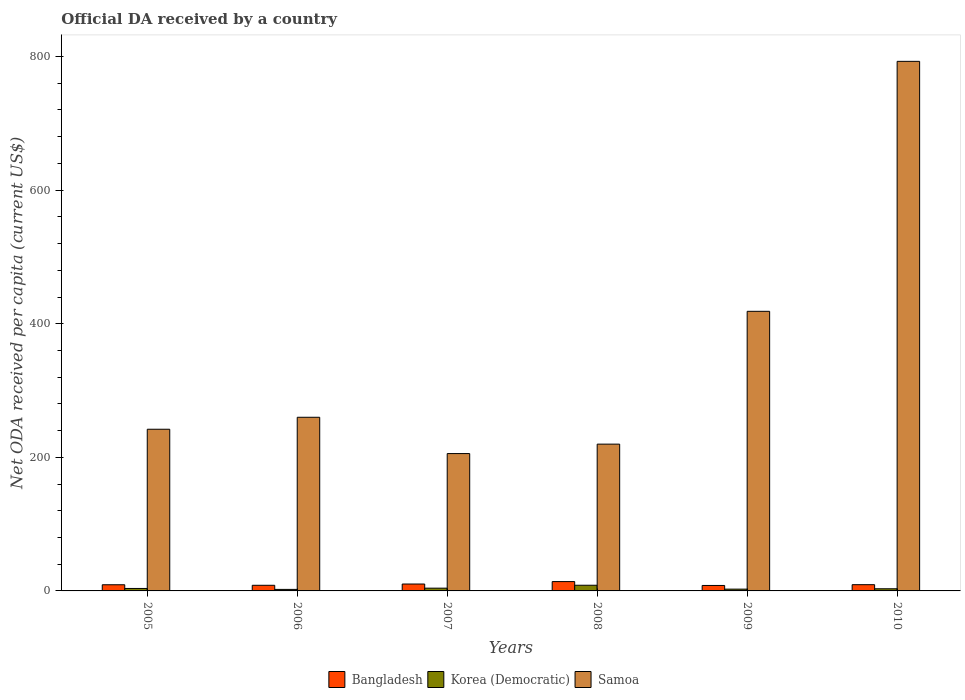How many different coloured bars are there?
Offer a terse response. 3. How many groups of bars are there?
Ensure brevity in your answer.  6. What is the ODA received in in Korea (Democratic) in 2009?
Offer a terse response. 2.68. Across all years, what is the maximum ODA received in in Korea (Democratic)?
Your response must be concise. 8.5. Across all years, what is the minimum ODA received in in Samoa?
Your answer should be compact. 205.61. What is the total ODA received in in Bangladesh in the graph?
Provide a short and direct response. 59.47. What is the difference between the ODA received in in Korea (Democratic) in 2006 and that in 2007?
Your answer should be very brief. -1.84. What is the difference between the ODA received in in Samoa in 2010 and the ODA received in in Bangladesh in 2009?
Your response must be concise. 784.6. What is the average ODA received in in Korea (Democratic) per year?
Keep it short and to the point. 4.08. In the year 2007, what is the difference between the ODA received in in Bangladesh and ODA received in in Korea (Democratic)?
Your response must be concise. 6.22. What is the ratio of the ODA received in in Samoa in 2009 to that in 2010?
Offer a terse response. 0.53. Is the ODA received in in Korea (Democratic) in 2005 less than that in 2010?
Make the answer very short. No. Is the difference between the ODA received in in Bangladesh in 2005 and 2006 greater than the difference between the ODA received in in Korea (Democratic) in 2005 and 2006?
Your response must be concise. No. What is the difference between the highest and the second highest ODA received in in Bangladesh?
Give a very brief answer. 3.63. What is the difference between the highest and the lowest ODA received in in Samoa?
Your answer should be compact. 587.17. Is the sum of the ODA received in in Samoa in 2005 and 2007 greater than the maximum ODA received in in Korea (Democratic) across all years?
Ensure brevity in your answer.  Yes. What does the 3rd bar from the left in 2006 represents?
Your answer should be compact. Samoa. What does the 1st bar from the right in 2008 represents?
Make the answer very short. Samoa. Is it the case that in every year, the sum of the ODA received in in Samoa and ODA received in in Bangladesh is greater than the ODA received in in Korea (Democratic)?
Give a very brief answer. Yes. What is the difference between two consecutive major ticks on the Y-axis?
Provide a short and direct response. 200. Are the values on the major ticks of Y-axis written in scientific E-notation?
Your answer should be very brief. No. Does the graph contain any zero values?
Ensure brevity in your answer.  No. Does the graph contain grids?
Offer a terse response. No. Where does the legend appear in the graph?
Provide a succinct answer. Bottom center. How are the legend labels stacked?
Make the answer very short. Horizontal. What is the title of the graph?
Give a very brief answer. Official DA received by a country. What is the label or title of the Y-axis?
Your answer should be compact. Net ODA received per capita (current US$). What is the Net ODA received per capita (current US$) in Bangladesh in 2005?
Ensure brevity in your answer.  9.23. What is the Net ODA received per capita (current US$) in Korea (Democratic) in 2005?
Your answer should be very brief. 3.68. What is the Net ODA received per capita (current US$) of Samoa in 2005?
Keep it short and to the point. 242.04. What is the Net ODA received per capita (current US$) of Bangladesh in 2006?
Ensure brevity in your answer.  8.43. What is the Net ODA received per capita (current US$) of Korea (Democratic) in 2006?
Make the answer very short. 2.28. What is the Net ODA received per capita (current US$) of Samoa in 2006?
Keep it short and to the point. 259.95. What is the Net ODA received per capita (current US$) of Bangladesh in 2007?
Make the answer very short. 10.34. What is the Net ODA received per capita (current US$) in Korea (Democratic) in 2007?
Offer a very short reply. 4.12. What is the Net ODA received per capita (current US$) in Samoa in 2007?
Give a very brief answer. 205.61. What is the Net ODA received per capita (current US$) of Bangladesh in 2008?
Your answer should be very brief. 13.97. What is the Net ODA received per capita (current US$) in Korea (Democratic) in 2008?
Provide a succinct answer. 8.5. What is the Net ODA received per capita (current US$) in Samoa in 2008?
Your answer should be very brief. 219.74. What is the Net ODA received per capita (current US$) in Bangladesh in 2009?
Make the answer very short. 8.18. What is the Net ODA received per capita (current US$) in Korea (Democratic) in 2009?
Provide a short and direct response. 2.68. What is the Net ODA received per capita (current US$) in Samoa in 2009?
Keep it short and to the point. 418.57. What is the Net ODA received per capita (current US$) in Bangladesh in 2010?
Provide a short and direct response. 9.33. What is the Net ODA received per capita (current US$) in Korea (Democratic) in 2010?
Keep it short and to the point. 3.22. What is the Net ODA received per capita (current US$) of Samoa in 2010?
Your answer should be very brief. 792.78. Across all years, what is the maximum Net ODA received per capita (current US$) in Bangladesh?
Your answer should be very brief. 13.97. Across all years, what is the maximum Net ODA received per capita (current US$) of Korea (Democratic)?
Provide a succinct answer. 8.5. Across all years, what is the maximum Net ODA received per capita (current US$) in Samoa?
Offer a terse response. 792.78. Across all years, what is the minimum Net ODA received per capita (current US$) of Bangladesh?
Offer a terse response. 8.18. Across all years, what is the minimum Net ODA received per capita (current US$) in Korea (Democratic)?
Offer a very short reply. 2.28. Across all years, what is the minimum Net ODA received per capita (current US$) of Samoa?
Provide a short and direct response. 205.61. What is the total Net ODA received per capita (current US$) of Bangladesh in the graph?
Keep it short and to the point. 59.47. What is the total Net ODA received per capita (current US$) in Korea (Democratic) in the graph?
Offer a very short reply. 24.47. What is the total Net ODA received per capita (current US$) of Samoa in the graph?
Your response must be concise. 2138.7. What is the difference between the Net ODA received per capita (current US$) of Bangladesh in 2005 and that in 2006?
Your response must be concise. 0.8. What is the difference between the Net ODA received per capita (current US$) of Korea (Democratic) in 2005 and that in 2006?
Your answer should be compact. 1.4. What is the difference between the Net ODA received per capita (current US$) of Samoa in 2005 and that in 2006?
Keep it short and to the point. -17.91. What is the difference between the Net ODA received per capita (current US$) of Bangladesh in 2005 and that in 2007?
Your answer should be very brief. -1.11. What is the difference between the Net ODA received per capita (current US$) in Korea (Democratic) in 2005 and that in 2007?
Keep it short and to the point. -0.44. What is the difference between the Net ODA received per capita (current US$) of Samoa in 2005 and that in 2007?
Keep it short and to the point. 36.43. What is the difference between the Net ODA received per capita (current US$) in Bangladesh in 2005 and that in 2008?
Your response must be concise. -4.74. What is the difference between the Net ODA received per capita (current US$) in Korea (Democratic) in 2005 and that in 2008?
Give a very brief answer. -4.83. What is the difference between the Net ODA received per capita (current US$) in Samoa in 2005 and that in 2008?
Provide a succinct answer. 22.3. What is the difference between the Net ODA received per capita (current US$) in Samoa in 2005 and that in 2009?
Provide a short and direct response. -176.53. What is the difference between the Net ODA received per capita (current US$) of Bangladesh in 2005 and that in 2010?
Offer a very short reply. -0.11. What is the difference between the Net ODA received per capita (current US$) of Korea (Democratic) in 2005 and that in 2010?
Your answer should be very brief. 0.46. What is the difference between the Net ODA received per capita (current US$) of Samoa in 2005 and that in 2010?
Ensure brevity in your answer.  -550.74. What is the difference between the Net ODA received per capita (current US$) in Bangladesh in 2006 and that in 2007?
Offer a terse response. -1.91. What is the difference between the Net ODA received per capita (current US$) in Korea (Democratic) in 2006 and that in 2007?
Your answer should be very brief. -1.84. What is the difference between the Net ODA received per capita (current US$) of Samoa in 2006 and that in 2007?
Offer a terse response. 54.34. What is the difference between the Net ODA received per capita (current US$) of Bangladesh in 2006 and that in 2008?
Ensure brevity in your answer.  -5.54. What is the difference between the Net ODA received per capita (current US$) of Korea (Democratic) in 2006 and that in 2008?
Provide a short and direct response. -6.22. What is the difference between the Net ODA received per capita (current US$) of Samoa in 2006 and that in 2008?
Your answer should be compact. 40.21. What is the difference between the Net ODA received per capita (current US$) in Bangladesh in 2006 and that in 2009?
Provide a succinct answer. 0.25. What is the difference between the Net ODA received per capita (current US$) of Korea (Democratic) in 2006 and that in 2009?
Make the answer very short. -0.4. What is the difference between the Net ODA received per capita (current US$) of Samoa in 2006 and that in 2009?
Make the answer very short. -158.62. What is the difference between the Net ODA received per capita (current US$) in Bangladesh in 2006 and that in 2010?
Offer a very short reply. -0.9. What is the difference between the Net ODA received per capita (current US$) in Korea (Democratic) in 2006 and that in 2010?
Make the answer very short. -0.94. What is the difference between the Net ODA received per capita (current US$) of Samoa in 2006 and that in 2010?
Give a very brief answer. -532.83. What is the difference between the Net ODA received per capita (current US$) of Bangladesh in 2007 and that in 2008?
Your response must be concise. -3.63. What is the difference between the Net ODA received per capita (current US$) of Korea (Democratic) in 2007 and that in 2008?
Make the answer very short. -4.39. What is the difference between the Net ODA received per capita (current US$) in Samoa in 2007 and that in 2008?
Your answer should be very brief. -14.13. What is the difference between the Net ODA received per capita (current US$) in Bangladesh in 2007 and that in 2009?
Provide a succinct answer. 2.16. What is the difference between the Net ODA received per capita (current US$) in Korea (Democratic) in 2007 and that in 2009?
Provide a succinct answer. 1.44. What is the difference between the Net ODA received per capita (current US$) of Samoa in 2007 and that in 2009?
Provide a short and direct response. -212.96. What is the difference between the Net ODA received per capita (current US$) in Bangladesh in 2007 and that in 2010?
Ensure brevity in your answer.  1. What is the difference between the Net ODA received per capita (current US$) in Samoa in 2007 and that in 2010?
Ensure brevity in your answer.  -587.17. What is the difference between the Net ODA received per capita (current US$) in Bangladesh in 2008 and that in 2009?
Your answer should be compact. 5.79. What is the difference between the Net ODA received per capita (current US$) in Korea (Democratic) in 2008 and that in 2009?
Provide a short and direct response. 5.83. What is the difference between the Net ODA received per capita (current US$) in Samoa in 2008 and that in 2009?
Keep it short and to the point. -198.83. What is the difference between the Net ODA received per capita (current US$) of Bangladesh in 2008 and that in 2010?
Give a very brief answer. 4.63. What is the difference between the Net ODA received per capita (current US$) of Korea (Democratic) in 2008 and that in 2010?
Your answer should be very brief. 5.29. What is the difference between the Net ODA received per capita (current US$) in Samoa in 2008 and that in 2010?
Make the answer very short. -573.03. What is the difference between the Net ODA received per capita (current US$) in Bangladesh in 2009 and that in 2010?
Provide a succinct answer. -1.16. What is the difference between the Net ODA received per capita (current US$) of Korea (Democratic) in 2009 and that in 2010?
Ensure brevity in your answer.  -0.54. What is the difference between the Net ODA received per capita (current US$) of Samoa in 2009 and that in 2010?
Make the answer very short. -374.21. What is the difference between the Net ODA received per capita (current US$) in Bangladesh in 2005 and the Net ODA received per capita (current US$) in Korea (Democratic) in 2006?
Provide a short and direct response. 6.95. What is the difference between the Net ODA received per capita (current US$) of Bangladesh in 2005 and the Net ODA received per capita (current US$) of Samoa in 2006?
Offer a very short reply. -250.72. What is the difference between the Net ODA received per capita (current US$) in Korea (Democratic) in 2005 and the Net ODA received per capita (current US$) in Samoa in 2006?
Provide a short and direct response. -256.27. What is the difference between the Net ODA received per capita (current US$) of Bangladesh in 2005 and the Net ODA received per capita (current US$) of Korea (Democratic) in 2007?
Offer a terse response. 5.11. What is the difference between the Net ODA received per capita (current US$) in Bangladesh in 2005 and the Net ODA received per capita (current US$) in Samoa in 2007?
Make the answer very short. -196.38. What is the difference between the Net ODA received per capita (current US$) of Korea (Democratic) in 2005 and the Net ODA received per capita (current US$) of Samoa in 2007?
Ensure brevity in your answer.  -201.93. What is the difference between the Net ODA received per capita (current US$) in Bangladesh in 2005 and the Net ODA received per capita (current US$) in Korea (Democratic) in 2008?
Your answer should be compact. 0.72. What is the difference between the Net ODA received per capita (current US$) in Bangladesh in 2005 and the Net ODA received per capita (current US$) in Samoa in 2008?
Your answer should be compact. -210.52. What is the difference between the Net ODA received per capita (current US$) of Korea (Democratic) in 2005 and the Net ODA received per capita (current US$) of Samoa in 2008?
Offer a very short reply. -216.07. What is the difference between the Net ODA received per capita (current US$) of Bangladesh in 2005 and the Net ODA received per capita (current US$) of Korea (Democratic) in 2009?
Offer a very short reply. 6.55. What is the difference between the Net ODA received per capita (current US$) in Bangladesh in 2005 and the Net ODA received per capita (current US$) in Samoa in 2009?
Provide a succinct answer. -409.34. What is the difference between the Net ODA received per capita (current US$) of Korea (Democratic) in 2005 and the Net ODA received per capita (current US$) of Samoa in 2009?
Provide a succinct answer. -414.89. What is the difference between the Net ODA received per capita (current US$) in Bangladesh in 2005 and the Net ODA received per capita (current US$) in Korea (Democratic) in 2010?
Offer a very short reply. 6.01. What is the difference between the Net ODA received per capita (current US$) of Bangladesh in 2005 and the Net ODA received per capita (current US$) of Samoa in 2010?
Provide a short and direct response. -783.55. What is the difference between the Net ODA received per capita (current US$) of Korea (Democratic) in 2005 and the Net ODA received per capita (current US$) of Samoa in 2010?
Give a very brief answer. -789.1. What is the difference between the Net ODA received per capita (current US$) in Bangladesh in 2006 and the Net ODA received per capita (current US$) in Korea (Democratic) in 2007?
Provide a succinct answer. 4.31. What is the difference between the Net ODA received per capita (current US$) of Bangladesh in 2006 and the Net ODA received per capita (current US$) of Samoa in 2007?
Keep it short and to the point. -197.18. What is the difference between the Net ODA received per capita (current US$) in Korea (Democratic) in 2006 and the Net ODA received per capita (current US$) in Samoa in 2007?
Your response must be concise. -203.33. What is the difference between the Net ODA received per capita (current US$) of Bangladesh in 2006 and the Net ODA received per capita (current US$) of Korea (Democratic) in 2008?
Offer a very short reply. -0.07. What is the difference between the Net ODA received per capita (current US$) in Bangladesh in 2006 and the Net ODA received per capita (current US$) in Samoa in 2008?
Provide a succinct answer. -211.31. What is the difference between the Net ODA received per capita (current US$) of Korea (Democratic) in 2006 and the Net ODA received per capita (current US$) of Samoa in 2008?
Offer a terse response. -217.46. What is the difference between the Net ODA received per capita (current US$) in Bangladesh in 2006 and the Net ODA received per capita (current US$) in Korea (Democratic) in 2009?
Provide a succinct answer. 5.76. What is the difference between the Net ODA received per capita (current US$) in Bangladesh in 2006 and the Net ODA received per capita (current US$) in Samoa in 2009?
Offer a very short reply. -410.14. What is the difference between the Net ODA received per capita (current US$) of Korea (Democratic) in 2006 and the Net ODA received per capita (current US$) of Samoa in 2009?
Offer a very short reply. -416.29. What is the difference between the Net ODA received per capita (current US$) of Bangladesh in 2006 and the Net ODA received per capita (current US$) of Korea (Democratic) in 2010?
Your response must be concise. 5.21. What is the difference between the Net ODA received per capita (current US$) of Bangladesh in 2006 and the Net ODA received per capita (current US$) of Samoa in 2010?
Provide a succinct answer. -784.35. What is the difference between the Net ODA received per capita (current US$) of Korea (Democratic) in 2006 and the Net ODA received per capita (current US$) of Samoa in 2010?
Offer a very short reply. -790.5. What is the difference between the Net ODA received per capita (current US$) of Bangladesh in 2007 and the Net ODA received per capita (current US$) of Korea (Democratic) in 2008?
Give a very brief answer. 1.83. What is the difference between the Net ODA received per capita (current US$) of Bangladesh in 2007 and the Net ODA received per capita (current US$) of Samoa in 2008?
Make the answer very short. -209.41. What is the difference between the Net ODA received per capita (current US$) of Korea (Democratic) in 2007 and the Net ODA received per capita (current US$) of Samoa in 2008?
Offer a terse response. -215.63. What is the difference between the Net ODA received per capita (current US$) in Bangladesh in 2007 and the Net ODA received per capita (current US$) in Korea (Democratic) in 2009?
Provide a short and direct response. 7.66. What is the difference between the Net ODA received per capita (current US$) in Bangladesh in 2007 and the Net ODA received per capita (current US$) in Samoa in 2009?
Your answer should be very brief. -408.23. What is the difference between the Net ODA received per capita (current US$) in Korea (Democratic) in 2007 and the Net ODA received per capita (current US$) in Samoa in 2009?
Give a very brief answer. -414.45. What is the difference between the Net ODA received per capita (current US$) in Bangladesh in 2007 and the Net ODA received per capita (current US$) in Korea (Democratic) in 2010?
Give a very brief answer. 7.12. What is the difference between the Net ODA received per capita (current US$) in Bangladesh in 2007 and the Net ODA received per capita (current US$) in Samoa in 2010?
Provide a succinct answer. -782.44. What is the difference between the Net ODA received per capita (current US$) in Korea (Democratic) in 2007 and the Net ODA received per capita (current US$) in Samoa in 2010?
Your answer should be compact. -788.66. What is the difference between the Net ODA received per capita (current US$) of Bangladesh in 2008 and the Net ODA received per capita (current US$) of Korea (Democratic) in 2009?
Offer a terse response. 11.29. What is the difference between the Net ODA received per capita (current US$) in Bangladesh in 2008 and the Net ODA received per capita (current US$) in Samoa in 2009?
Provide a short and direct response. -404.6. What is the difference between the Net ODA received per capita (current US$) of Korea (Democratic) in 2008 and the Net ODA received per capita (current US$) of Samoa in 2009?
Ensure brevity in your answer.  -410.07. What is the difference between the Net ODA received per capita (current US$) in Bangladesh in 2008 and the Net ODA received per capita (current US$) in Korea (Democratic) in 2010?
Your response must be concise. 10.75. What is the difference between the Net ODA received per capita (current US$) in Bangladesh in 2008 and the Net ODA received per capita (current US$) in Samoa in 2010?
Your answer should be compact. -778.81. What is the difference between the Net ODA received per capita (current US$) of Korea (Democratic) in 2008 and the Net ODA received per capita (current US$) of Samoa in 2010?
Your answer should be compact. -784.27. What is the difference between the Net ODA received per capita (current US$) of Bangladesh in 2009 and the Net ODA received per capita (current US$) of Korea (Democratic) in 2010?
Your answer should be very brief. 4.96. What is the difference between the Net ODA received per capita (current US$) in Bangladesh in 2009 and the Net ODA received per capita (current US$) in Samoa in 2010?
Provide a short and direct response. -784.6. What is the difference between the Net ODA received per capita (current US$) of Korea (Democratic) in 2009 and the Net ODA received per capita (current US$) of Samoa in 2010?
Provide a short and direct response. -790.1. What is the average Net ODA received per capita (current US$) of Bangladesh per year?
Ensure brevity in your answer.  9.91. What is the average Net ODA received per capita (current US$) of Korea (Democratic) per year?
Ensure brevity in your answer.  4.08. What is the average Net ODA received per capita (current US$) of Samoa per year?
Your answer should be compact. 356.45. In the year 2005, what is the difference between the Net ODA received per capita (current US$) in Bangladesh and Net ODA received per capita (current US$) in Korea (Democratic)?
Offer a terse response. 5.55. In the year 2005, what is the difference between the Net ODA received per capita (current US$) in Bangladesh and Net ODA received per capita (current US$) in Samoa?
Give a very brief answer. -232.81. In the year 2005, what is the difference between the Net ODA received per capita (current US$) of Korea (Democratic) and Net ODA received per capita (current US$) of Samoa?
Offer a very short reply. -238.36. In the year 2006, what is the difference between the Net ODA received per capita (current US$) in Bangladesh and Net ODA received per capita (current US$) in Korea (Democratic)?
Provide a succinct answer. 6.15. In the year 2006, what is the difference between the Net ODA received per capita (current US$) in Bangladesh and Net ODA received per capita (current US$) in Samoa?
Your response must be concise. -251.52. In the year 2006, what is the difference between the Net ODA received per capita (current US$) of Korea (Democratic) and Net ODA received per capita (current US$) of Samoa?
Your answer should be very brief. -257.67. In the year 2007, what is the difference between the Net ODA received per capita (current US$) of Bangladesh and Net ODA received per capita (current US$) of Korea (Democratic)?
Offer a terse response. 6.22. In the year 2007, what is the difference between the Net ODA received per capita (current US$) in Bangladesh and Net ODA received per capita (current US$) in Samoa?
Offer a very short reply. -195.27. In the year 2007, what is the difference between the Net ODA received per capita (current US$) of Korea (Democratic) and Net ODA received per capita (current US$) of Samoa?
Keep it short and to the point. -201.49. In the year 2008, what is the difference between the Net ODA received per capita (current US$) of Bangladesh and Net ODA received per capita (current US$) of Korea (Democratic)?
Provide a succinct answer. 5.46. In the year 2008, what is the difference between the Net ODA received per capita (current US$) of Bangladesh and Net ODA received per capita (current US$) of Samoa?
Give a very brief answer. -205.78. In the year 2008, what is the difference between the Net ODA received per capita (current US$) in Korea (Democratic) and Net ODA received per capita (current US$) in Samoa?
Your answer should be very brief. -211.24. In the year 2009, what is the difference between the Net ODA received per capita (current US$) in Bangladesh and Net ODA received per capita (current US$) in Korea (Democratic)?
Provide a succinct answer. 5.5. In the year 2009, what is the difference between the Net ODA received per capita (current US$) in Bangladesh and Net ODA received per capita (current US$) in Samoa?
Your answer should be very brief. -410.39. In the year 2009, what is the difference between the Net ODA received per capita (current US$) in Korea (Democratic) and Net ODA received per capita (current US$) in Samoa?
Give a very brief answer. -415.89. In the year 2010, what is the difference between the Net ODA received per capita (current US$) of Bangladesh and Net ODA received per capita (current US$) of Korea (Democratic)?
Provide a short and direct response. 6.11. In the year 2010, what is the difference between the Net ODA received per capita (current US$) in Bangladesh and Net ODA received per capita (current US$) in Samoa?
Provide a succinct answer. -783.45. In the year 2010, what is the difference between the Net ODA received per capita (current US$) in Korea (Democratic) and Net ODA received per capita (current US$) in Samoa?
Keep it short and to the point. -789.56. What is the ratio of the Net ODA received per capita (current US$) in Bangladesh in 2005 to that in 2006?
Provide a succinct answer. 1.09. What is the ratio of the Net ODA received per capita (current US$) of Korea (Democratic) in 2005 to that in 2006?
Your answer should be compact. 1.61. What is the ratio of the Net ODA received per capita (current US$) of Samoa in 2005 to that in 2006?
Offer a terse response. 0.93. What is the ratio of the Net ODA received per capita (current US$) in Bangladesh in 2005 to that in 2007?
Offer a very short reply. 0.89. What is the ratio of the Net ODA received per capita (current US$) of Korea (Democratic) in 2005 to that in 2007?
Keep it short and to the point. 0.89. What is the ratio of the Net ODA received per capita (current US$) in Samoa in 2005 to that in 2007?
Make the answer very short. 1.18. What is the ratio of the Net ODA received per capita (current US$) of Bangladesh in 2005 to that in 2008?
Provide a succinct answer. 0.66. What is the ratio of the Net ODA received per capita (current US$) in Korea (Democratic) in 2005 to that in 2008?
Offer a very short reply. 0.43. What is the ratio of the Net ODA received per capita (current US$) in Samoa in 2005 to that in 2008?
Offer a terse response. 1.1. What is the ratio of the Net ODA received per capita (current US$) in Bangladesh in 2005 to that in 2009?
Provide a short and direct response. 1.13. What is the ratio of the Net ODA received per capita (current US$) of Korea (Democratic) in 2005 to that in 2009?
Give a very brief answer. 1.37. What is the ratio of the Net ODA received per capita (current US$) in Samoa in 2005 to that in 2009?
Ensure brevity in your answer.  0.58. What is the ratio of the Net ODA received per capita (current US$) in Bangladesh in 2005 to that in 2010?
Offer a terse response. 0.99. What is the ratio of the Net ODA received per capita (current US$) of Korea (Democratic) in 2005 to that in 2010?
Your response must be concise. 1.14. What is the ratio of the Net ODA received per capita (current US$) in Samoa in 2005 to that in 2010?
Keep it short and to the point. 0.31. What is the ratio of the Net ODA received per capita (current US$) in Bangladesh in 2006 to that in 2007?
Offer a terse response. 0.82. What is the ratio of the Net ODA received per capita (current US$) of Korea (Democratic) in 2006 to that in 2007?
Your answer should be compact. 0.55. What is the ratio of the Net ODA received per capita (current US$) in Samoa in 2006 to that in 2007?
Provide a short and direct response. 1.26. What is the ratio of the Net ODA received per capita (current US$) of Bangladesh in 2006 to that in 2008?
Your response must be concise. 0.6. What is the ratio of the Net ODA received per capita (current US$) of Korea (Democratic) in 2006 to that in 2008?
Make the answer very short. 0.27. What is the ratio of the Net ODA received per capita (current US$) in Samoa in 2006 to that in 2008?
Your response must be concise. 1.18. What is the ratio of the Net ODA received per capita (current US$) in Bangladesh in 2006 to that in 2009?
Your response must be concise. 1.03. What is the ratio of the Net ODA received per capita (current US$) in Korea (Democratic) in 2006 to that in 2009?
Offer a terse response. 0.85. What is the ratio of the Net ODA received per capita (current US$) of Samoa in 2006 to that in 2009?
Offer a very short reply. 0.62. What is the ratio of the Net ODA received per capita (current US$) of Bangladesh in 2006 to that in 2010?
Make the answer very short. 0.9. What is the ratio of the Net ODA received per capita (current US$) of Korea (Democratic) in 2006 to that in 2010?
Provide a short and direct response. 0.71. What is the ratio of the Net ODA received per capita (current US$) in Samoa in 2006 to that in 2010?
Keep it short and to the point. 0.33. What is the ratio of the Net ODA received per capita (current US$) of Bangladesh in 2007 to that in 2008?
Provide a short and direct response. 0.74. What is the ratio of the Net ODA received per capita (current US$) of Korea (Democratic) in 2007 to that in 2008?
Make the answer very short. 0.48. What is the ratio of the Net ODA received per capita (current US$) of Samoa in 2007 to that in 2008?
Give a very brief answer. 0.94. What is the ratio of the Net ODA received per capita (current US$) of Bangladesh in 2007 to that in 2009?
Your response must be concise. 1.26. What is the ratio of the Net ODA received per capita (current US$) of Korea (Democratic) in 2007 to that in 2009?
Your answer should be compact. 1.54. What is the ratio of the Net ODA received per capita (current US$) in Samoa in 2007 to that in 2009?
Give a very brief answer. 0.49. What is the ratio of the Net ODA received per capita (current US$) of Bangladesh in 2007 to that in 2010?
Your answer should be compact. 1.11. What is the ratio of the Net ODA received per capita (current US$) in Korea (Democratic) in 2007 to that in 2010?
Ensure brevity in your answer.  1.28. What is the ratio of the Net ODA received per capita (current US$) in Samoa in 2007 to that in 2010?
Your answer should be very brief. 0.26. What is the ratio of the Net ODA received per capita (current US$) in Bangladesh in 2008 to that in 2009?
Provide a short and direct response. 1.71. What is the ratio of the Net ODA received per capita (current US$) of Korea (Democratic) in 2008 to that in 2009?
Your response must be concise. 3.18. What is the ratio of the Net ODA received per capita (current US$) in Samoa in 2008 to that in 2009?
Make the answer very short. 0.53. What is the ratio of the Net ODA received per capita (current US$) of Bangladesh in 2008 to that in 2010?
Ensure brevity in your answer.  1.5. What is the ratio of the Net ODA received per capita (current US$) of Korea (Democratic) in 2008 to that in 2010?
Ensure brevity in your answer.  2.64. What is the ratio of the Net ODA received per capita (current US$) in Samoa in 2008 to that in 2010?
Make the answer very short. 0.28. What is the ratio of the Net ODA received per capita (current US$) of Bangladesh in 2009 to that in 2010?
Provide a short and direct response. 0.88. What is the ratio of the Net ODA received per capita (current US$) in Korea (Democratic) in 2009 to that in 2010?
Offer a terse response. 0.83. What is the ratio of the Net ODA received per capita (current US$) of Samoa in 2009 to that in 2010?
Your answer should be compact. 0.53. What is the difference between the highest and the second highest Net ODA received per capita (current US$) of Bangladesh?
Ensure brevity in your answer.  3.63. What is the difference between the highest and the second highest Net ODA received per capita (current US$) in Korea (Democratic)?
Your answer should be compact. 4.39. What is the difference between the highest and the second highest Net ODA received per capita (current US$) in Samoa?
Make the answer very short. 374.21. What is the difference between the highest and the lowest Net ODA received per capita (current US$) in Bangladesh?
Provide a short and direct response. 5.79. What is the difference between the highest and the lowest Net ODA received per capita (current US$) in Korea (Democratic)?
Your answer should be very brief. 6.22. What is the difference between the highest and the lowest Net ODA received per capita (current US$) in Samoa?
Provide a short and direct response. 587.17. 